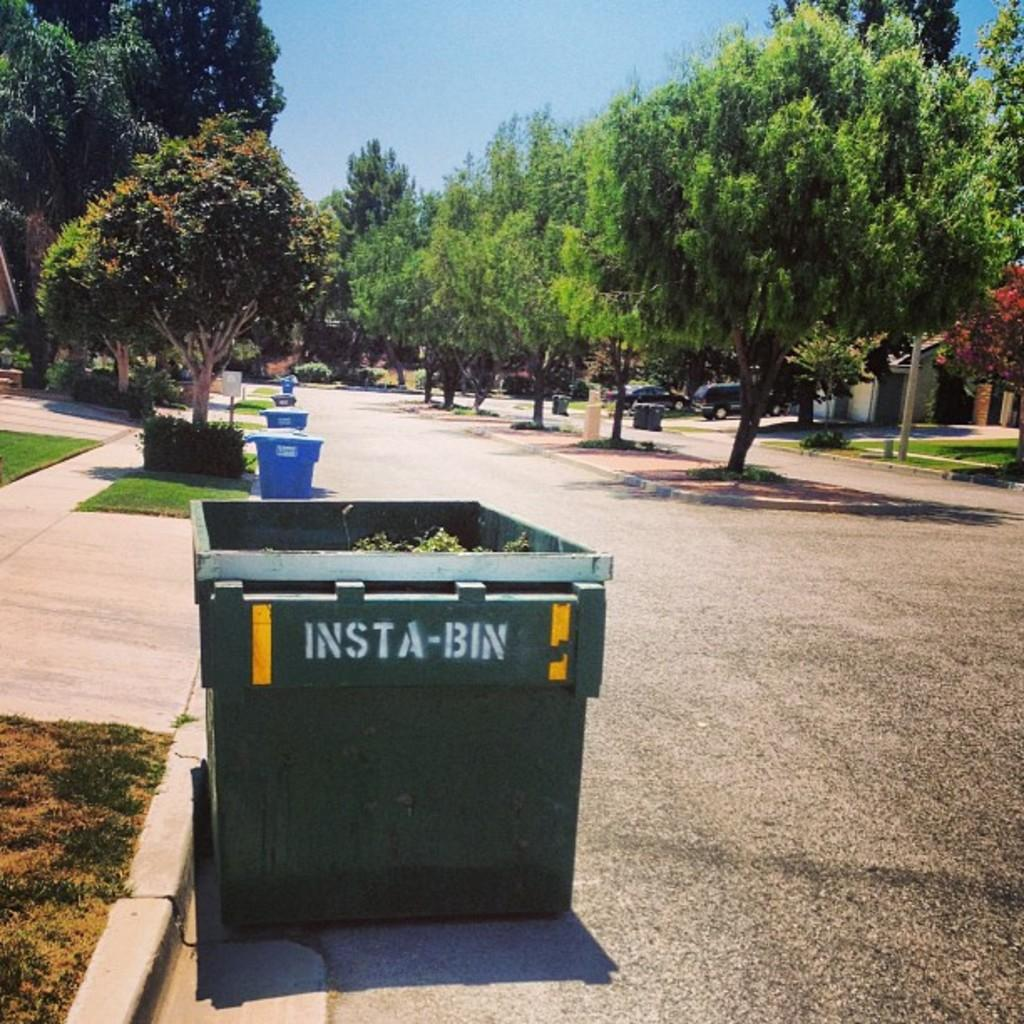<image>
Create a compact narrative representing the image presented. A green box called an INSTA-BIN sit at the bottom of a driveway 